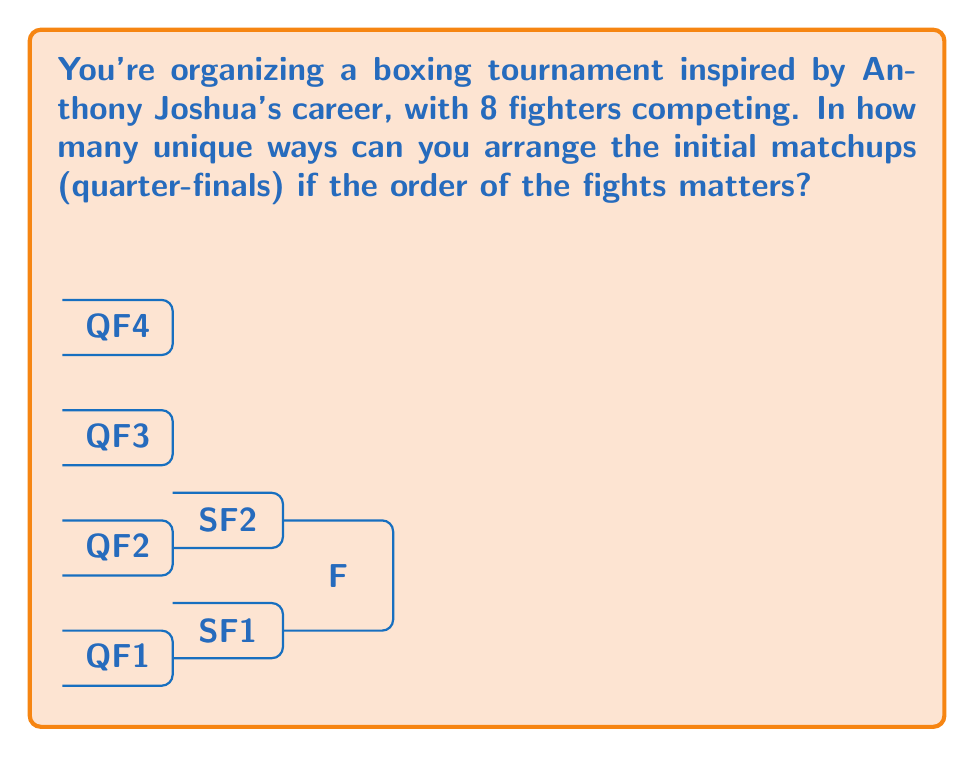Can you solve this math problem? Let's approach this step-by-step using permutation groups:

1) We have 8 fighters, which we need to arrange into 4 pairs for the quarter-finals.

2) For the first pair, we have 8 choices for the first fighter and 7 for the second. This gives us $8 \times 7 = 56$ possibilities for the first pair.

3) For the second pair, we have 6 choices for the first fighter and 5 for the second. This gives us $6 \times 5 = 30$ possibilities for the second pair.

4) For the third pair, we have 4 choices for the first fighter and 3 for the second. This gives us $4 \times 3 = 12$ possibilities for the third pair.

5) The last pair is determined once we've arranged the first three pairs.

6) Now, we need to consider the order of these pairs. We can arrange 4 pairs in $4!$ ways.

7) Putting this all together, we can calculate the total number of unique arrangements:

   $$(8 \times 7) \times (6 \times 5) \times (4 \times 3) \times 4!$$

8) Simplifying:
   $$56 \times 30 \times 12 \times 24 = 483,840$$

This represents the order of the permutation group $S_8$ acting on the set of quarter-final matchups.
Answer: 483,840 